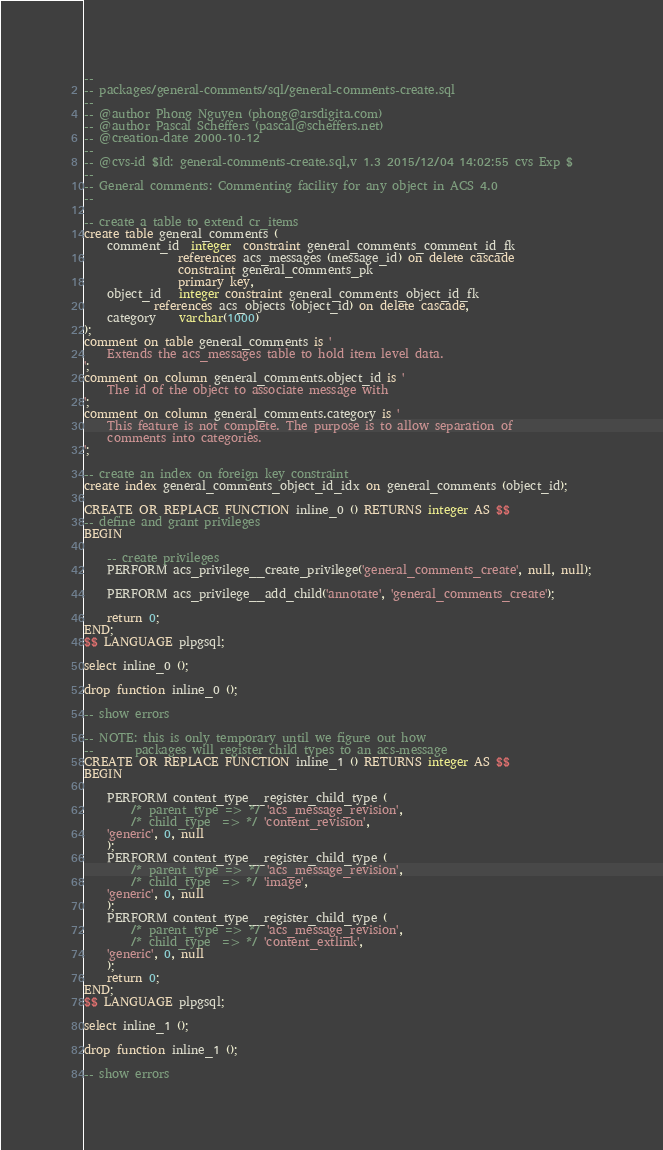<code> <loc_0><loc_0><loc_500><loc_500><_SQL_>--
-- packages/general-comments/sql/general-comments-create.sql
--
-- @author Phong Nguyen (phong@arsdigita.com)
-- @author Pascal Scheffers (pascal@scheffers.net)
-- @creation-date 2000-10-12
--
-- @cvs-id $Id: general-comments-create.sql,v 1.3 2015/12/04 14:02:55 cvs Exp $
--
-- General comments: Commenting facility for any object in ACS 4.0
-- 

-- create a table to extend cr_items
create table general_comments (
    comment_id  integer  constraint general_comments_comment_id_fk
                references acs_messages (message_id) on delete cascade 
                constraint general_comments_pk
                primary key,
    object_id   integer constraint general_comments_object_id_fk
	        references acs_objects (object_id) on delete cascade,
    category    varchar(1000)
);
comment on table general_comments is '
    Extends the acs_messages table to hold item level data.
'; 
comment on column general_comments.object_id is '
    The id of the object to associate message with
';
comment on column general_comments.category is '
    This feature is not complete. The purpose is to allow separation of 
    comments into categories.  
';

-- create an index on foreign key constraint
create index general_comments_object_id_idx on general_comments (object_id);

CREATE OR REPLACE FUNCTION inline_0 () RETURNS integer AS $$
-- define and grant privileges
BEGIN

    -- create privileges
    PERFORM acs_privilege__create_privilege('general_comments_create', null, null);

    PERFORM acs_privilege__add_child('annotate', 'general_comments_create');

    return 0;
END;
$$ LANGUAGE plpgsql;

select inline_0 ();

drop function inline_0 ();

-- show errors

-- NOTE: this is only temporary until we figure out how
--       packages will register child types to an acs-message
CREATE OR REPLACE FUNCTION inline_1 () RETURNS integer AS $$
BEGIN

    PERFORM content_type__register_child_type (
        /* parent_type => */ 'acs_message_revision',
        /* child_type  => */ 'content_revision',
	'generic', 0, null
    );
    PERFORM content_type__register_child_type (
        /* parent_type => */ 'acs_message_revision',
        /* child_type  => */ 'image',
	'generic', 0, null
    );
    PERFORM content_type__register_child_type (
        /* parent_type => */ 'acs_message_revision',
        /* child_type  => */ 'content_extlink',
	'generic', 0, null
    );
    return 0;
END;
$$ LANGUAGE plpgsql;

select inline_1 ();

drop function inline_1 ();

-- show errors


</code> 